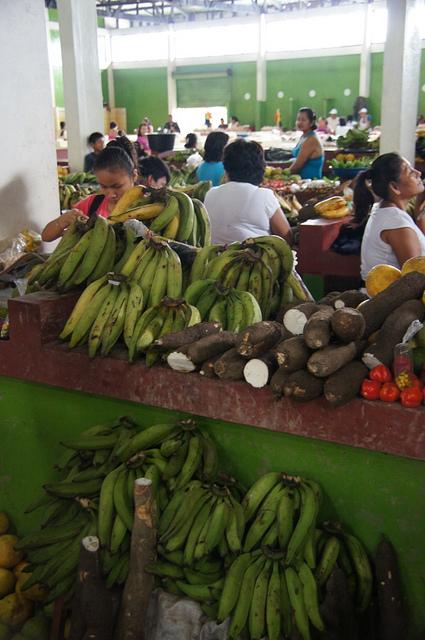Are all the bananas green?
Write a very short answer. Yes. What color is the counters?
Quick response, please. Brown. Are the banana hanging ripe?
Write a very short answer. No. Are the bananas ripe?
Quick response, please. No. Is this a market?
Keep it brief. Yes. What color are the bunches of bananas?
Be succinct. Green. Is it daytime?
Answer briefly. Yes. 